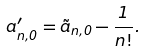<formula> <loc_0><loc_0><loc_500><loc_500>a ^ { \prime } _ { n , 0 } = \tilde { a } _ { n , 0 } - \frac { 1 } { n ! } .</formula> 